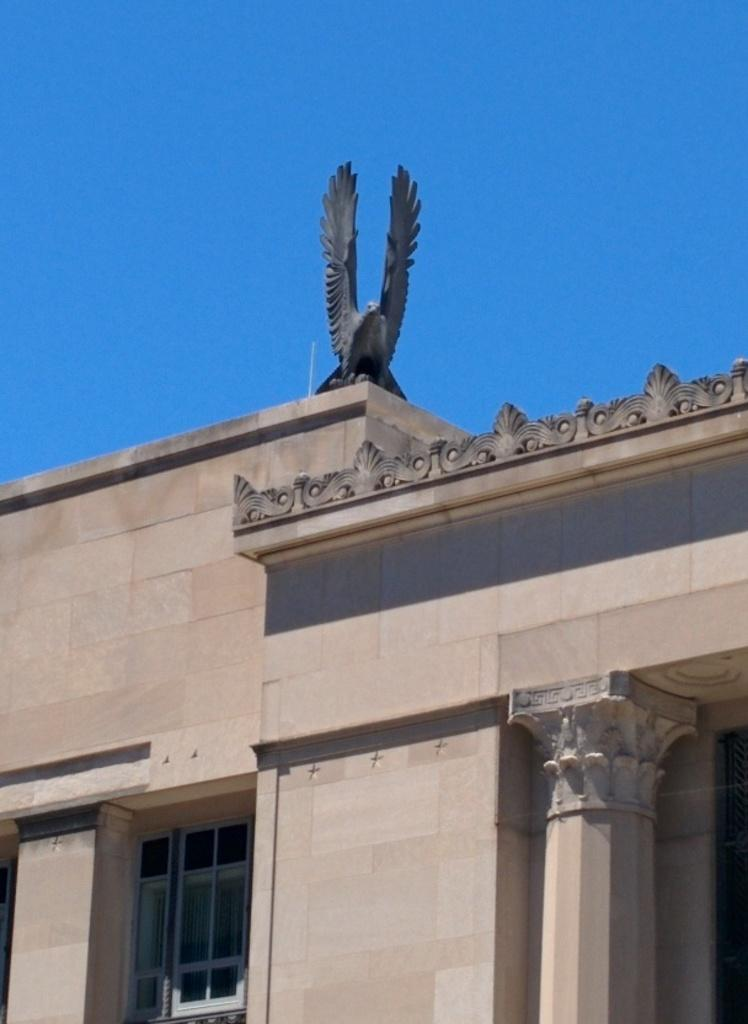What type of material is used for the building's wall in the image? The building has a brick wall. What architectural features can be seen on the building? The building has windows and pillars. Is there any artwork or decoration on the building? Yes, there is a statue of a bird on the building. What can be seen in the background of the image? The sky is visible in the background. What type of authority does the bird statue have in the image? The bird statue is a decorative element and does not have any authority in the image. Can you hear the thunder in the image? There is no mention of thunder or any auditory elements in the image, so it cannot be heard. 